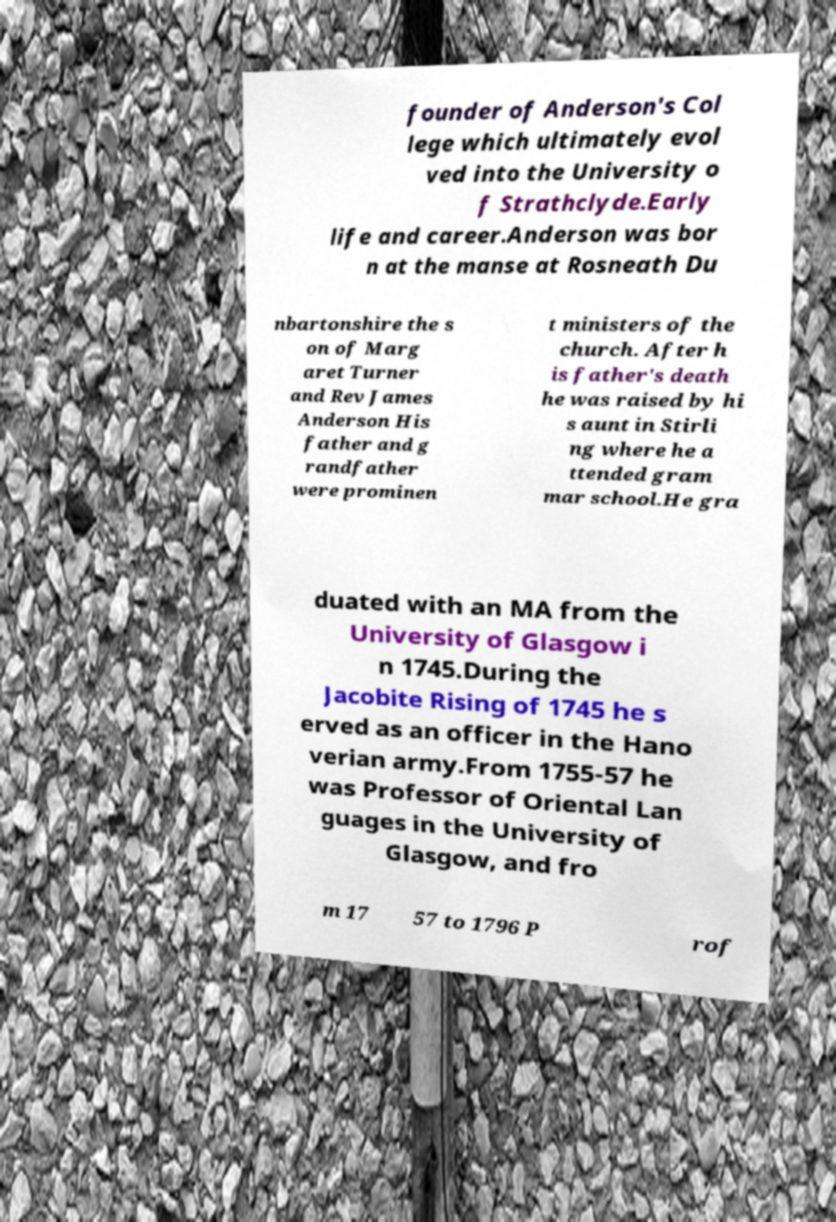Can you accurately transcribe the text from the provided image for me? founder of Anderson's Col lege which ultimately evol ved into the University o f Strathclyde.Early life and career.Anderson was bor n at the manse at Rosneath Du nbartonshire the s on of Marg aret Turner and Rev James Anderson His father and g randfather were prominen t ministers of the church. After h is father's death he was raised by hi s aunt in Stirli ng where he a ttended gram mar school.He gra duated with an MA from the University of Glasgow i n 1745.During the Jacobite Rising of 1745 he s erved as an officer in the Hano verian army.From 1755-57 he was Professor of Oriental Lan guages in the University of Glasgow, and fro m 17 57 to 1796 P rof 